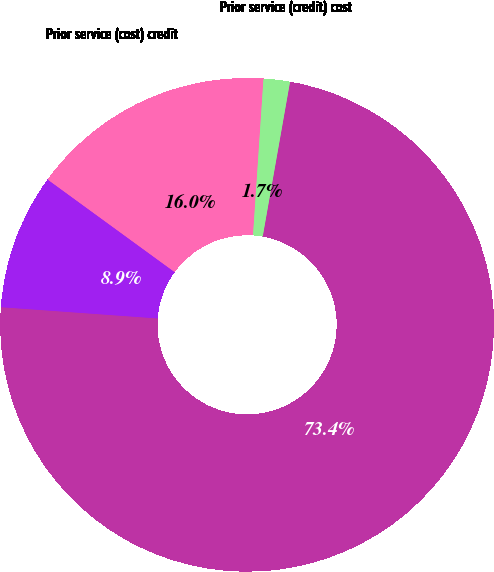Convert chart to OTSL. <chart><loc_0><loc_0><loc_500><loc_500><pie_chart><fcel>Years Ended December 31<fcel>Net (loss) gain arising during<fcel>Prior service (cost) credit<fcel>Prior service (credit) cost<nl><fcel>73.36%<fcel>8.88%<fcel>16.04%<fcel>1.72%<nl></chart> 